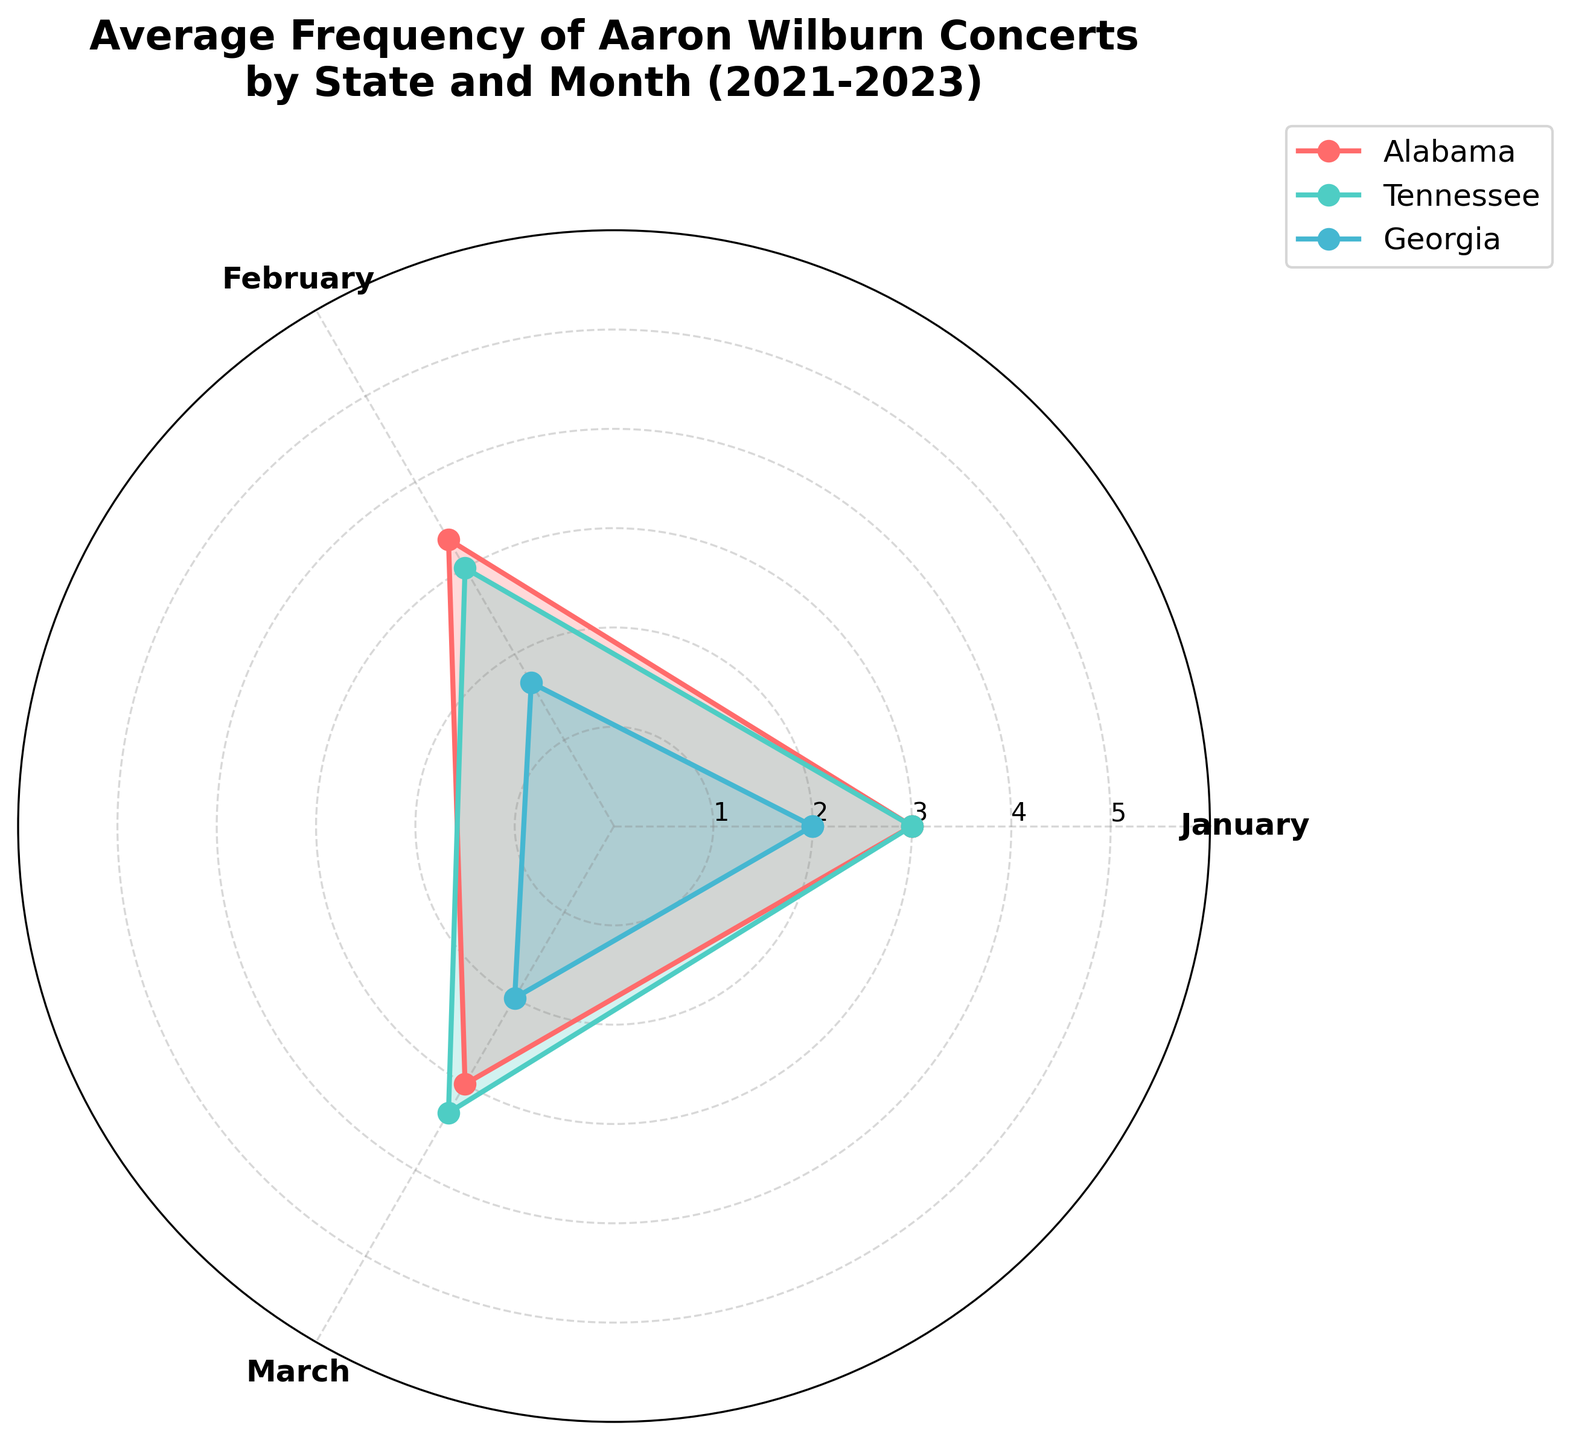What is the title of the radar chart? The title is usually placed at the top of the chart where it provides a summary of what the chart represents. From the provided code, the title is "Average Frequency of Aaron Wilburn Concerts by State and Month (2021-2023)"
Answer: Average Frequency of Aaron Wilburn Concerts by State and Month (2021-2023) Which state shows the highest average concert frequency in March? To determine this, look at the March points for all the groups (states). Compare their values visually. Tennessee has the highest point in March.
Answer: Tennessee How many states are compared in this radar chart? Each group (state) is represented by a different line/area on the radar chart. From the code, data for three states (Alabama, Tennessee, and Georgia) is plotted.
Answer: Three Which month shows the greatest variation among the states? To find the greatest variation, look for the month where the distances between the state's values are the largest. This is visually noticeable by comparing the spread of the points for each month. March shows the greatest variation.
Answer: March Between Alabama and Georgia, which state had more frequent concerts on average? Visually compare the overall area covered by the radar chart for Alabama and Georgia respectively. Alabama's area is larger indicating a higher average frequency.
Answer: Alabama What is the average frequency of concerts for Alabama in February from 2021 to 2023? To calculate the average, add the values for February over the three years and divide by 3. (2 + 3 + 3) / 3 = 8 / 3 ≈ 2.67
Answer: About 2.67 Did any state have an increase in concert frequency from January to March across the observed years? Visually check the trend from January to March for each state in the form of increasing or decreasing values. Tennessee shows an upward trend from January to March.
Answer: Tennessee Which state maintains the most consistent concert frequency from January through March? Consistency would be indicated by points close together and forming a regular shape. Alabama’s values from January to March are closest to each other.
Answer: Alabama How does the concert frequency of Aaron Wilburn in Georgia compare between January and February on average? Visually compare the radar points for Georgia in January and February. The points indicate almost similar frequencies, but January may be slightly lower than February.
Answer: January is slightly lower than February Are any of the months uniformly distributed in terms of concert frequency across all states? Uniform distribution would imply almost equal values for all states in a particular month. January seems to be the closest to a uniform distribution with all values tightly clustered.
Answer: January 